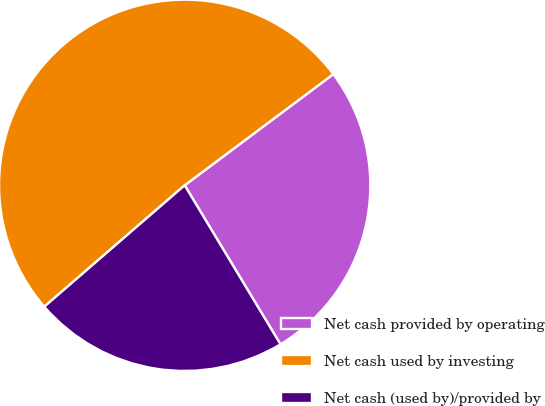Convert chart to OTSL. <chart><loc_0><loc_0><loc_500><loc_500><pie_chart><fcel>Net cash provided by operating<fcel>Net cash used by investing<fcel>Net cash (used by)/provided by<nl><fcel>26.59%<fcel>51.13%<fcel>22.28%<nl></chart> 